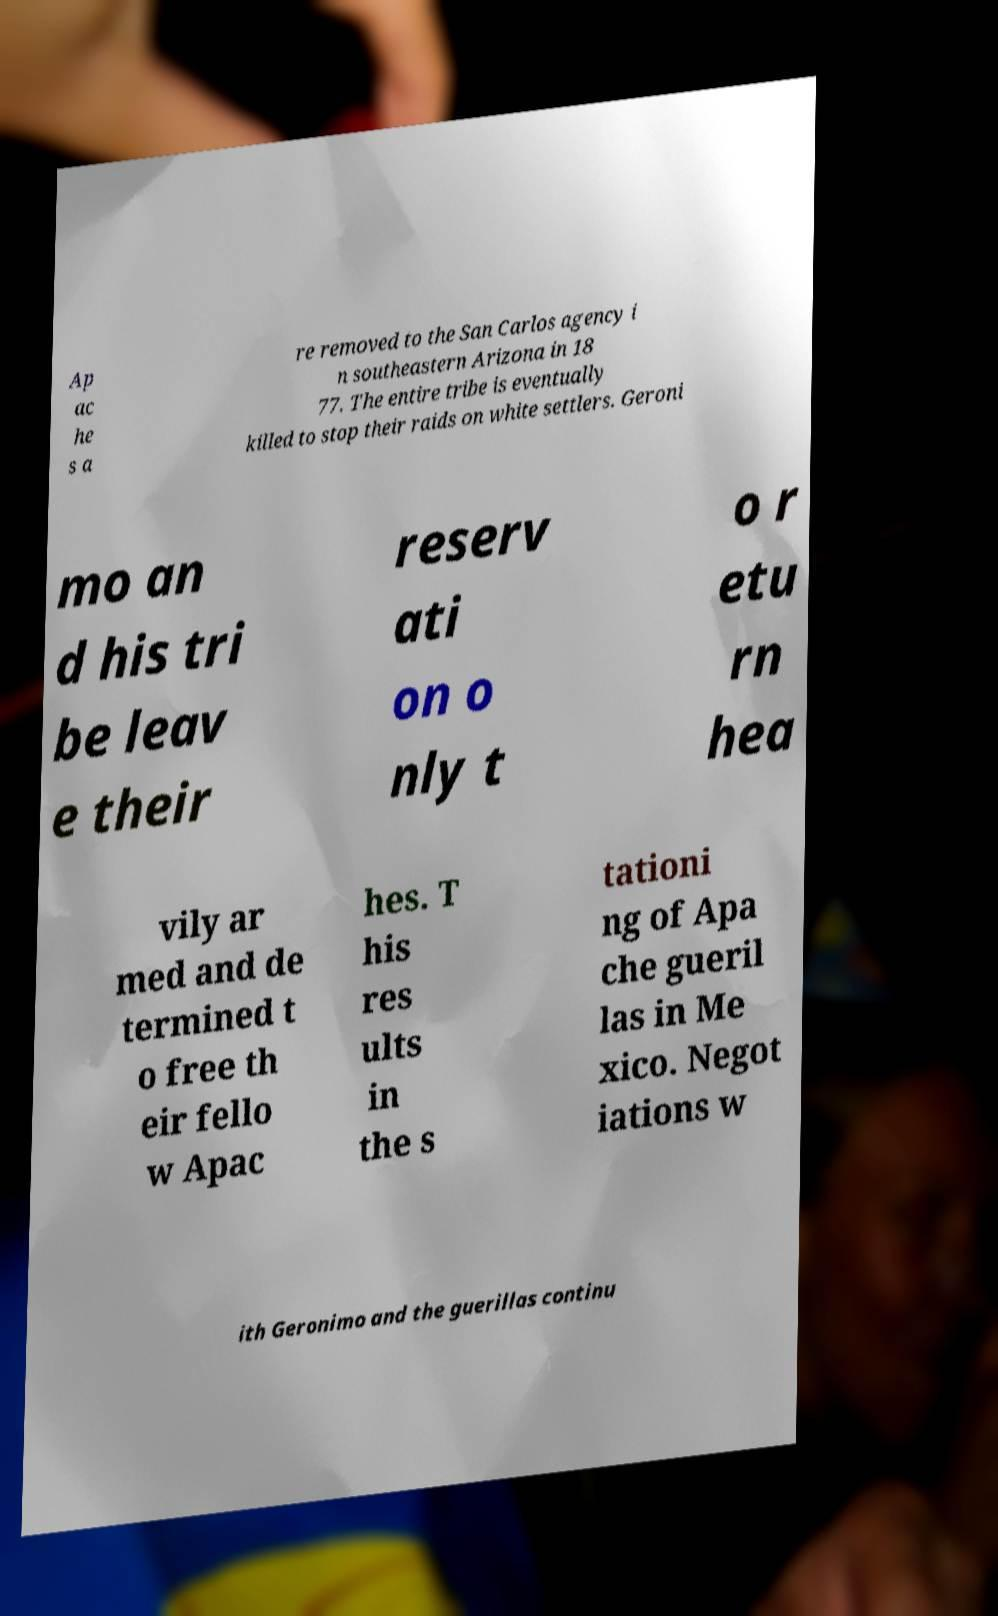Could you assist in decoding the text presented in this image and type it out clearly? Ap ac he s a re removed to the San Carlos agency i n southeastern Arizona in 18 77. The entire tribe is eventually killed to stop their raids on white settlers. Geroni mo an d his tri be leav e their reserv ati on o nly t o r etu rn hea vily ar med and de termined t o free th eir fello w Apac hes. T his res ults in the s tationi ng of Apa che gueril las in Me xico. Negot iations w ith Geronimo and the guerillas continu 